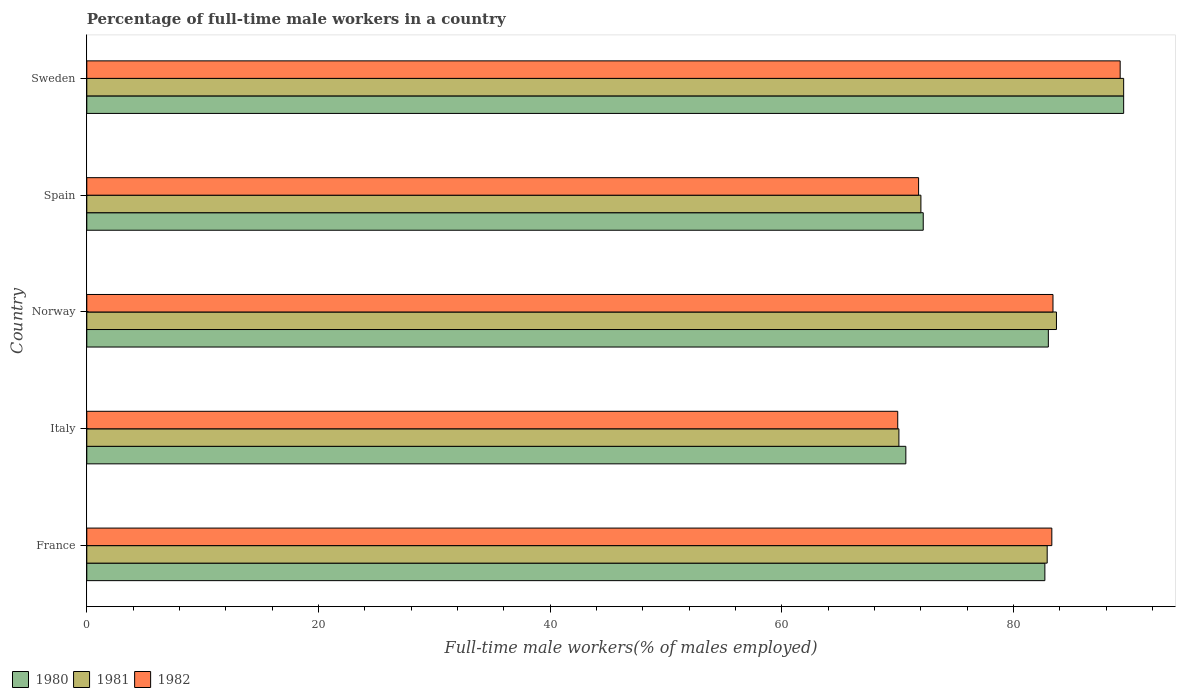Are the number of bars per tick equal to the number of legend labels?
Ensure brevity in your answer.  Yes. How many bars are there on the 4th tick from the top?
Keep it short and to the point. 3. In how many cases, is the number of bars for a given country not equal to the number of legend labels?
Your answer should be very brief. 0. What is the percentage of full-time male workers in 1982 in France?
Ensure brevity in your answer.  83.3. Across all countries, what is the maximum percentage of full-time male workers in 1980?
Make the answer very short. 89.5. Across all countries, what is the minimum percentage of full-time male workers in 1981?
Provide a succinct answer. 70.1. What is the total percentage of full-time male workers in 1982 in the graph?
Provide a succinct answer. 397.7. What is the difference between the percentage of full-time male workers in 1982 in Spain and that in Sweden?
Offer a very short reply. -17.4. What is the difference between the percentage of full-time male workers in 1982 in Norway and the percentage of full-time male workers in 1980 in Sweden?
Your response must be concise. -6.1. What is the average percentage of full-time male workers in 1982 per country?
Provide a short and direct response. 79.54. What is the difference between the percentage of full-time male workers in 1982 and percentage of full-time male workers in 1981 in France?
Offer a very short reply. 0.4. In how many countries, is the percentage of full-time male workers in 1982 greater than 64 %?
Your answer should be compact. 5. What is the ratio of the percentage of full-time male workers in 1981 in France to that in Spain?
Keep it short and to the point. 1.15. What is the difference between the highest and the second highest percentage of full-time male workers in 1981?
Offer a terse response. 5.8. What is the difference between the highest and the lowest percentage of full-time male workers in 1980?
Provide a succinct answer. 18.8. What does the 3rd bar from the bottom in Norway represents?
Your response must be concise. 1982. Is it the case that in every country, the sum of the percentage of full-time male workers in 1980 and percentage of full-time male workers in 1982 is greater than the percentage of full-time male workers in 1981?
Give a very brief answer. Yes. How many bars are there?
Keep it short and to the point. 15. Does the graph contain grids?
Keep it short and to the point. No. How many legend labels are there?
Your response must be concise. 3. What is the title of the graph?
Ensure brevity in your answer.  Percentage of full-time male workers in a country. Does "1976" appear as one of the legend labels in the graph?
Ensure brevity in your answer.  No. What is the label or title of the X-axis?
Provide a short and direct response. Full-time male workers(% of males employed). What is the label or title of the Y-axis?
Make the answer very short. Country. What is the Full-time male workers(% of males employed) of 1980 in France?
Offer a terse response. 82.7. What is the Full-time male workers(% of males employed) in 1981 in France?
Give a very brief answer. 82.9. What is the Full-time male workers(% of males employed) of 1982 in France?
Offer a terse response. 83.3. What is the Full-time male workers(% of males employed) of 1980 in Italy?
Provide a succinct answer. 70.7. What is the Full-time male workers(% of males employed) of 1981 in Italy?
Provide a short and direct response. 70.1. What is the Full-time male workers(% of males employed) of 1981 in Norway?
Make the answer very short. 83.7. What is the Full-time male workers(% of males employed) of 1982 in Norway?
Keep it short and to the point. 83.4. What is the Full-time male workers(% of males employed) of 1980 in Spain?
Your answer should be compact. 72.2. What is the Full-time male workers(% of males employed) of 1981 in Spain?
Your response must be concise. 72. What is the Full-time male workers(% of males employed) of 1982 in Spain?
Offer a terse response. 71.8. What is the Full-time male workers(% of males employed) in 1980 in Sweden?
Provide a succinct answer. 89.5. What is the Full-time male workers(% of males employed) of 1981 in Sweden?
Provide a short and direct response. 89.5. What is the Full-time male workers(% of males employed) of 1982 in Sweden?
Make the answer very short. 89.2. Across all countries, what is the maximum Full-time male workers(% of males employed) of 1980?
Provide a succinct answer. 89.5. Across all countries, what is the maximum Full-time male workers(% of males employed) in 1981?
Keep it short and to the point. 89.5. Across all countries, what is the maximum Full-time male workers(% of males employed) in 1982?
Make the answer very short. 89.2. Across all countries, what is the minimum Full-time male workers(% of males employed) in 1980?
Your answer should be very brief. 70.7. Across all countries, what is the minimum Full-time male workers(% of males employed) in 1981?
Make the answer very short. 70.1. Across all countries, what is the minimum Full-time male workers(% of males employed) in 1982?
Give a very brief answer. 70. What is the total Full-time male workers(% of males employed) of 1980 in the graph?
Offer a terse response. 398.1. What is the total Full-time male workers(% of males employed) in 1981 in the graph?
Ensure brevity in your answer.  398.2. What is the total Full-time male workers(% of males employed) in 1982 in the graph?
Your response must be concise. 397.7. What is the difference between the Full-time male workers(% of males employed) of 1980 in France and that in Italy?
Ensure brevity in your answer.  12. What is the difference between the Full-time male workers(% of males employed) of 1982 in France and that in Italy?
Offer a terse response. 13.3. What is the difference between the Full-time male workers(% of males employed) of 1980 in France and that in Norway?
Your answer should be compact. -0.3. What is the difference between the Full-time male workers(% of males employed) of 1980 in France and that in Spain?
Ensure brevity in your answer.  10.5. What is the difference between the Full-time male workers(% of males employed) in 1981 in France and that in Spain?
Your response must be concise. 10.9. What is the difference between the Full-time male workers(% of males employed) of 1982 in France and that in Spain?
Your answer should be compact. 11.5. What is the difference between the Full-time male workers(% of males employed) in 1982 in France and that in Sweden?
Give a very brief answer. -5.9. What is the difference between the Full-time male workers(% of males employed) of 1980 in Italy and that in Norway?
Offer a terse response. -12.3. What is the difference between the Full-time male workers(% of males employed) in 1981 in Italy and that in Norway?
Provide a succinct answer. -13.6. What is the difference between the Full-time male workers(% of males employed) in 1980 in Italy and that in Spain?
Ensure brevity in your answer.  -1.5. What is the difference between the Full-time male workers(% of males employed) of 1980 in Italy and that in Sweden?
Your answer should be very brief. -18.8. What is the difference between the Full-time male workers(% of males employed) in 1981 in Italy and that in Sweden?
Keep it short and to the point. -19.4. What is the difference between the Full-time male workers(% of males employed) of 1982 in Italy and that in Sweden?
Your answer should be compact. -19.2. What is the difference between the Full-time male workers(% of males employed) of 1980 in Norway and that in Spain?
Ensure brevity in your answer.  10.8. What is the difference between the Full-time male workers(% of males employed) in 1981 in Norway and that in Spain?
Offer a very short reply. 11.7. What is the difference between the Full-time male workers(% of males employed) of 1981 in Norway and that in Sweden?
Keep it short and to the point. -5.8. What is the difference between the Full-time male workers(% of males employed) in 1982 in Norway and that in Sweden?
Provide a short and direct response. -5.8. What is the difference between the Full-time male workers(% of males employed) in 1980 in Spain and that in Sweden?
Make the answer very short. -17.3. What is the difference between the Full-time male workers(% of males employed) of 1981 in Spain and that in Sweden?
Keep it short and to the point. -17.5. What is the difference between the Full-time male workers(% of males employed) in 1982 in Spain and that in Sweden?
Provide a short and direct response. -17.4. What is the difference between the Full-time male workers(% of males employed) in 1980 in France and the Full-time male workers(% of males employed) in 1981 in Italy?
Offer a terse response. 12.6. What is the difference between the Full-time male workers(% of males employed) in 1981 in France and the Full-time male workers(% of males employed) in 1982 in Norway?
Ensure brevity in your answer.  -0.5. What is the difference between the Full-time male workers(% of males employed) of 1980 in France and the Full-time male workers(% of males employed) of 1981 in Sweden?
Provide a succinct answer. -6.8. What is the difference between the Full-time male workers(% of males employed) in 1980 in Italy and the Full-time male workers(% of males employed) in 1981 in Norway?
Your answer should be compact. -13. What is the difference between the Full-time male workers(% of males employed) of 1980 in Italy and the Full-time male workers(% of males employed) of 1982 in Norway?
Your answer should be compact. -12.7. What is the difference between the Full-time male workers(% of males employed) of 1981 in Italy and the Full-time male workers(% of males employed) of 1982 in Norway?
Keep it short and to the point. -13.3. What is the difference between the Full-time male workers(% of males employed) of 1980 in Italy and the Full-time male workers(% of males employed) of 1981 in Sweden?
Provide a short and direct response. -18.8. What is the difference between the Full-time male workers(% of males employed) of 1980 in Italy and the Full-time male workers(% of males employed) of 1982 in Sweden?
Give a very brief answer. -18.5. What is the difference between the Full-time male workers(% of males employed) of 1981 in Italy and the Full-time male workers(% of males employed) of 1982 in Sweden?
Ensure brevity in your answer.  -19.1. What is the difference between the Full-time male workers(% of males employed) of 1980 in Norway and the Full-time male workers(% of males employed) of 1981 in Spain?
Your answer should be very brief. 11. What is the difference between the Full-time male workers(% of males employed) of 1980 in Norway and the Full-time male workers(% of males employed) of 1982 in Spain?
Provide a succinct answer. 11.2. What is the difference between the Full-time male workers(% of males employed) in 1981 in Norway and the Full-time male workers(% of males employed) in 1982 in Sweden?
Your answer should be compact. -5.5. What is the difference between the Full-time male workers(% of males employed) in 1980 in Spain and the Full-time male workers(% of males employed) in 1981 in Sweden?
Offer a terse response. -17.3. What is the difference between the Full-time male workers(% of males employed) in 1981 in Spain and the Full-time male workers(% of males employed) in 1982 in Sweden?
Ensure brevity in your answer.  -17.2. What is the average Full-time male workers(% of males employed) of 1980 per country?
Make the answer very short. 79.62. What is the average Full-time male workers(% of males employed) of 1981 per country?
Your answer should be compact. 79.64. What is the average Full-time male workers(% of males employed) of 1982 per country?
Your answer should be compact. 79.54. What is the difference between the Full-time male workers(% of males employed) in 1980 and Full-time male workers(% of males employed) in 1982 in Norway?
Make the answer very short. -0.4. What is the difference between the Full-time male workers(% of males employed) in 1981 and Full-time male workers(% of males employed) in 1982 in Norway?
Your answer should be compact. 0.3. What is the difference between the Full-time male workers(% of males employed) in 1980 and Full-time male workers(% of males employed) in 1981 in Spain?
Your answer should be very brief. 0.2. What is the difference between the Full-time male workers(% of males employed) of 1980 and Full-time male workers(% of males employed) of 1982 in Sweden?
Ensure brevity in your answer.  0.3. What is the ratio of the Full-time male workers(% of males employed) of 1980 in France to that in Italy?
Ensure brevity in your answer.  1.17. What is the ratio of the Full-time male workers(% of males employed) in 1981 in France to that in Italy?
Make the answer very short. 1.18. What is the ratio of the Full-time male workers(% of males employed) in 1982 in France to that in Italy?
Offer a terse response. 1.19. What is the ratio of the Full-time male workers(% of males employed) in 1980 in France to that in Norway?
Make the answer very short. 1. What is the ratio of the Full-time male workers(% of males employed) in 1981 in France to that in Norway?
Your response must be concise. 0.99. What is the ratio of the Full-time male workers(% of males employed) of 1980 in France to that in Spain?
Make the answer very short. 1.15. What is the ratio of the Full-time male workers(% of males employed) in 1981 in France to that in Spain?
Your answer should be very brief. 1.15. What is the ratio of the Full-time male workers(% of males employed) of 1982 in France to that in Spain?
Keep it short and to the point. 1.16. What is the ratio of the Full-time male workers(% of males employed) of 1980 in France to that in Sweden?
Make the answer very short. 0.92. What is the ratio of the Full-time male workers(% of males employed) of 1981 in France to that in Sweden?
Provide a short and direct response. 0.93. What is the ratio of the Full-time male workers(% of males employed) of 1982 in France to that in Sweden?
Your answer should be compact. 0.93. What is the ratio of the Full-time male workers(% of males employed) in 1980 in Italy to that in Norway?
Offer a very short reply. 0.85. What is the ratio of the Full-time male workers(% of males employed) in 1981 in Italy to that in Norway?
Offer a very short reply. 0.84. What is the ratio of the Full-time male workers(% of males employed) in 1982 in Italy to that in Norway?
Your response must be concise. 0.84. What is the ratio of the Full-time male workers(% of males employed) in 1980 in Italy to that in Spain?
Provide a succinct answer. 0.98. What is the ratio of the Full-time male workers(% of males employed) of 1981 in Italy to that in Spain?
Keep it short and to the point. 0.97. What is the ratio of the Full-time male workers(% of males employed) of 1982 in Italy to that in Spain?
Offer a terse response. 0.97. What is the ratio of the Full-time male workers(% of males employed) of 1980 in Italy to that in Sweden?
Provide a succinct answer. 0.79. What is the ratio of the Full-time male workers(% of males employed) of 1981 in Italy to that in Sweden?
Offer a very short reply. 0.78. What is the ratio of the Full-time male workers(% of males employed) in 1982 in Italy to that in Sweden?
Ensure brevity in your answer.  0.78. What is the ratio of the Full-time male workers(% of males employed) of 1980 in Norway to that in Spain?
Your response must be concise. 1.15. What is the ratio of the Full-time male workers(% of males employed) in 1981 in Norway to that in Spain?
Your answer should be compact. 1.16. What is the ratio of the Full-time male workers(% of males employed) in 1982 in Norway to that in Spain?
Your answer should be compact. 1.16. What is the ratio of the Full-time male workers(% of males employed) of 1980 in Norway to that in Sweden?
Offer a terse response. 0.93. What is the ratio of the Full-time male workers(% of males employed) in 1981 in Norway to that in Sweden?
Offer a very short reply. 0.94. What is the ratio of the Full-time male workers(% of males employed) of 1982 in Norway to that in Sweden?
Keep it short and to the point. 0.94. What is the ratio of the Full-time male workers(% of males employed) of 1980 in Spain to that in Sweden?
Offer a very short reply. 0.81. What is the ratio of the Full-time male workers(% of males employed) of 1981 in Spain to that in Sweden?
Your answer should be compact. 0.8. What is the ratio of the Full-time male workers(% of males employed) in 1982 in Spain to that in Sweden?
Keep it short and to the point. 0.8. What is the difference between the highest and the second highest Full-time male workers(% of males employed) of 1980?
Offer a very short reply. 6.5. What is the difference between the highest and the second highest Full-time male workers(% of males employed) of 1981?
Offer a terse response. 5.8. What is the difference between the highest and the second highest Full-time male workers(% of males employed) in 1982?
Your answer should be very brief. 5.8. What is the difference between the highest and the lowest Full-time male workers(% of males employed) of 1980?
Offer a very short reply. 18.8. What is the difference between the highest and the lowest Full-time male workers(% of males employed) of 1981?
Offer a terse response. 19.4. 